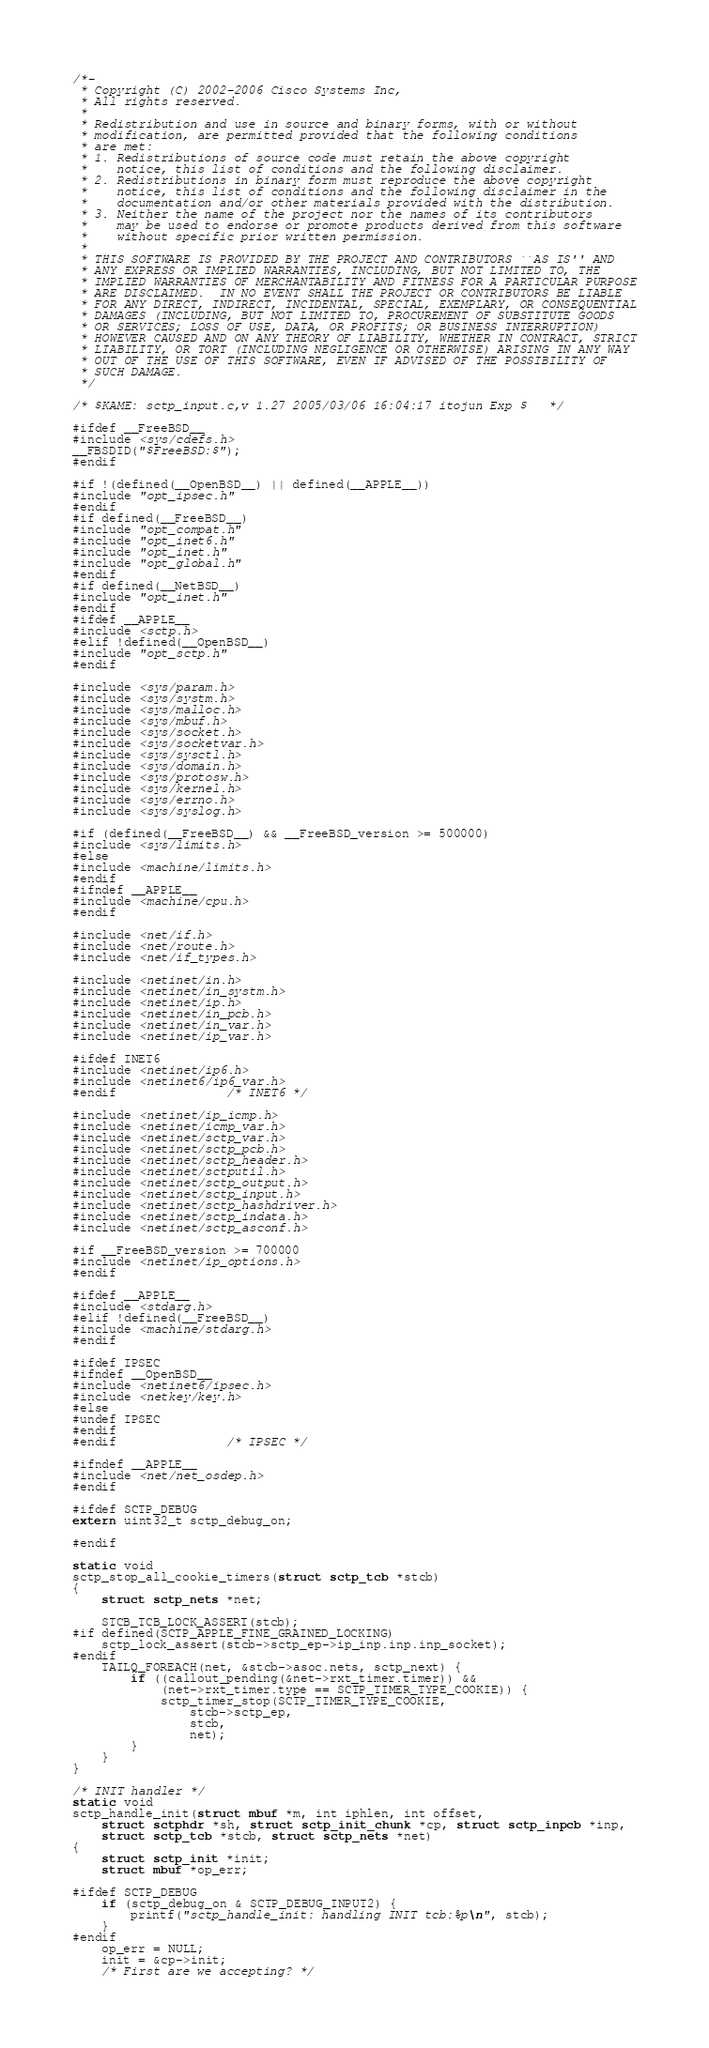<code> <loc_0><loc_0><loc_500><loc_500><_C_>/*-
 * Copyright (C) 2002-2006 Cisco Systems Inc,
 * All rights reserved.
 *
 * Redistribution and use in source and binary forms, with or without
 * modification, are permitted provided that the following conditions
 * are met:
 * 1. Redistributions of source code must retain the above copyright
 *    notice, this list of conditions and the following disclaimer.
 * 2. Redistributions in binary form must reproduce the above copyright
 *    notice, this list of conditions and the following disclaimer in the
 *    documentation and/or other materials provided with the distribution.
 * 3. Neither the name of the project nor the names of its contributors
 *    may be used to endorse or promote products derived from this software
 *    without specific prior written permission.
 *
 * THIS SOFTWARE IS PROVIDED BY THE PROJECT AND CONTRIBUTORS ``AS IS'' AND
 * ANY EXPRESS OR IMPLIED WARRANTIES, INCLUDING, BUT NOT LIMITED TO, THE
 * IMPLIED WARRANTIES OF MERCHANTABILITY AND FITNESS FOR A PARTICULAR PURPOSE
 * ARE DISCLAIMED.  IN NO EVENT SHALL THE PROJECT OR CONTRIBUTORS BE LIABLE
 * FOR ANY DIRECT, INDIRECT, INCIDENTAL, SPECIAL, EXEMPLARY, OR CONSEQUENTIAL
 * DAMAGES (INCLUDING, BUT NOT LIMITED TO, PROCUREMENT OF SUBSTITUTE GOODS
 * OR SERVICES; LOSS OF USE, DATA, OR PROFITS; OR BUSINESS INTERRUPTION)
 * HOWEVER CAUSED AND ON ANY THEORY OF LIABILITY, WHETHER IN CONTRACT, STRICT
 * LIABILITY, OR TORT (INCLUDING NEGLIGENCE OR OTHERWISE) ARISING IN ANY WAY
 * OUT OF THE USE OF THIS SOFTWARE, EVEN IF ADVISED OF THE POSSIBILITY OF
 * SUCH DAMAGE.
 */

/* $KAME: sctp_input.c,v 1.27 2005/03/06 16:04:17 itojun Exp $	 */

#ifdef __FreeBSD__
#include <sys/cdefs.h>
__FBSDID("$FreeBSD:$");
#endif

#if !(defined(__OpenBSD__) || defined(__APPLE__))
#include "opt_ipsec.h"
#endif
#if defined(__FreeBSD__)
#include "opt_compat.h"
#include "opt_inet6.h"
#include "opt_inet.h"
#include "opt_global.h"
#endif
#if defined(__NetBSD__)
#include "opt_inet.h"
#endif
#ifdef __APPLE__
#include <sctp.h>
#elif !defined(__OpenBSD__)
#include "opt_sctp.h"
#endif

#include <sys/param.h>
#include <sys/systm.h>
#include <sys/malloc.h>
#include <sys/mbuf.h>
#include <sys/socket.h>
#include <sys/socketvar.h>
#include <sys/sysctl.h>
#include <sys/domain.h>
#include <sys/protosw.h>
#include <sys/kernel.h>
#include <sys/errno.h>
#include <sys/syslog.h>

#if (defined(__FreeBSD__) && __FreeBSD_version >= 500000)
#include <sys/limits.h>
#else
#include <machine/limits.h>
#endif
#ifndef __APPLE__
#include <machine/cpu.h>
#endif

#include <net/if.h>
#include <net/route.h>
#include <net/if_types.h>

#include <netinet/in.h>
#include <netinet/in_systm.h>
#include <netinet/ip.h>
#include <netinet/in_pcb.h>
#include <netinet/in_var.h>
#include <netinet/ip_var.h>

#ifdef INET6
#include <netinet/ip6.h>
#include <netinet6/ip6_var.h>
#endif				/* INET6 */

#include <netinet/ip_icmp.h>
#include <netinet/icmp_var.h>
#include <netinet/sctp_var.h>
#include <netinet/sctp_pcb.h>
#include <netinet/sctp_header.h>
#include <netinet/sctputil.h>
#include <netinet/sctp_output.h>
#include <netinet/sctp_input.h>
#include <netinet/sctp_hashdriver.h>
#include <netinet/sctp_indata.h>
#include <netinet/sctp_asconf.h>

#if __FreeBSD_version >= 700000
#include <netinet/ip_options.h>
#endif

#ifdef __APPLE__
#include <stdarg.h>
#elif !defined(__FreeBSD__)
#include <machine/stdarg.h>
#endif

#ifdef IPSEC
#ifndef __OpenBSD__
#include <netinet6/ipsec.h>
#include <netkey/key.h>
#else
#undef IPSEC
#endif
#endif				/* IPSEC */

#ifndef __APPLE__
#include <net/net_osdep.h>
#endif

#ifdef SCTP_DEBUG
extern uint32_t sctp_debug_on;

#endif

static void
sctp_stop_all_cookie_timers(struct sctp_tcb *stcb)
{
	struct sctp_nets *net;

	STCB_TCB_LOCK_ASSERT(stcb);
#if defined(SCTP_APPLE_FINE_GRAINED_LOCKING)
	sctp_lock_assert(stcb->sctp_ep->ip_inp.inp.inp_socket);
#endif
	TAILQ_FOREACH(net, &stcb->asoc.nets, sctp_next) {
		if ((callout_pending(&net->rxt_timer.timer)) &&
		    (net->rxt_timer.type == SCTP_TIMER_TYPE_COOKIE)) {
			sctp_timer_stop(SCTP_TIMER_TYPE_COOKIE,
			    stcb->sctp_ep,
			    stcb,
			    net);
		}
	}
}

/* INIT handler */
static void
sctp_handle_init(struct mbuf *m, int iphlen, int offset,
    struct sctphdr *sh, struct sctp_init_chunk *cp, struct sctp_inpcb *inp,
    struct sctp_tcb *stcb, struct sctp_nets *net)
{
	struct sctp_init *init;
	struct mbuf *op_err;

#ifdef SCTP_DEBUG
	if (sctp_debug_on & SCTP_DEBUG_INPUT2) {
		printf("sctp_handle_init: handling INIT tcb:%p\n", stcb);
	}
#endif
	op_err = NULL;
	init = &cp->init;
	/* First are we accepting? */</code> 